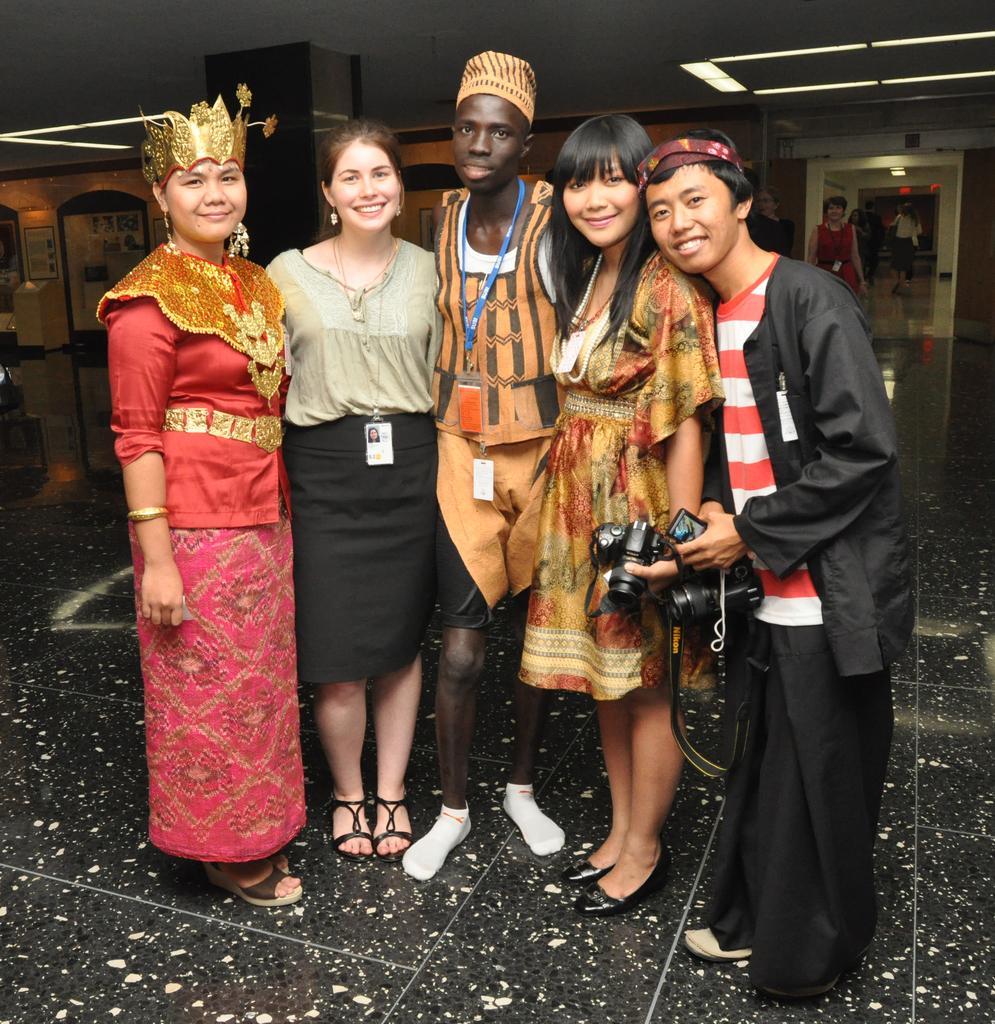In one or two sentences, can you explain what this image depicts? In the foreground of this image, there are five persons walking and a man and a woman are holding cameras. In the background, there are lights to the ceiling, wall, posters, boards and few persons walking on the floor. 